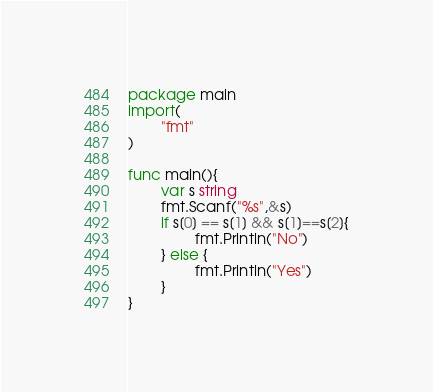Convert code to text. <code><loc_0><loc_0><loc_500><loc_500><_Go_>package main
import(
        "fmt"
)

func main(){
        var s string
        fmt.Scanf("%s",&s)
        if s[0] == s[1] && s[1]==s[2]{
                fmt.Println("No")
        } else {
                fmt.Println("Yes")
        }
}</code> 